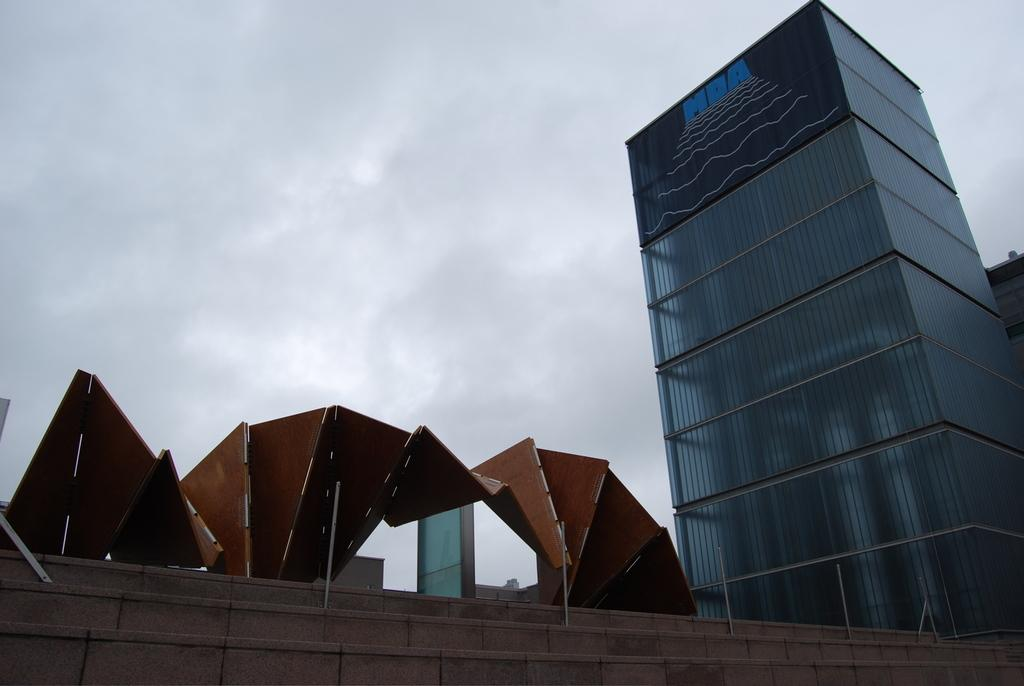What structure is located on the right side of the image? There is a building on the right side of the image. What architectural feature is on the left side of the image? There are steps on the left side of the image. What is associated with the steps in the image? There is an arch associated with the steps. What is visible in the sky in the image? The sky is visible in the image, and there are clouds in the sky. How many friends are sitting on the steps in the image? There are no friends present in the image; it only shows steps, an arch, and a building. What type of vein can be seen running through the building in the image? There is no vein visible in the image; it features a building, steps, an arch, and clouds in the sky. 